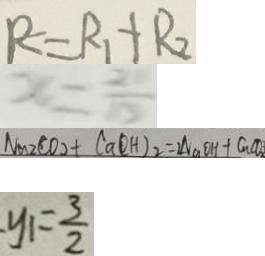Convert formula to latex. <formula><loc_0><loc_0><loc_500><loc_500>R = R _ { 1 } + R _ { 2 } 
 x = \frac { 2 } { 1 0 } 
 N a 2 C O _ { 2 } + C a ( O H ) _ { 2 } = 2 N a O H + C u C O _ { 2 } 
 y _ { 1 } = \frac { 3 } { 2 }</formula> 